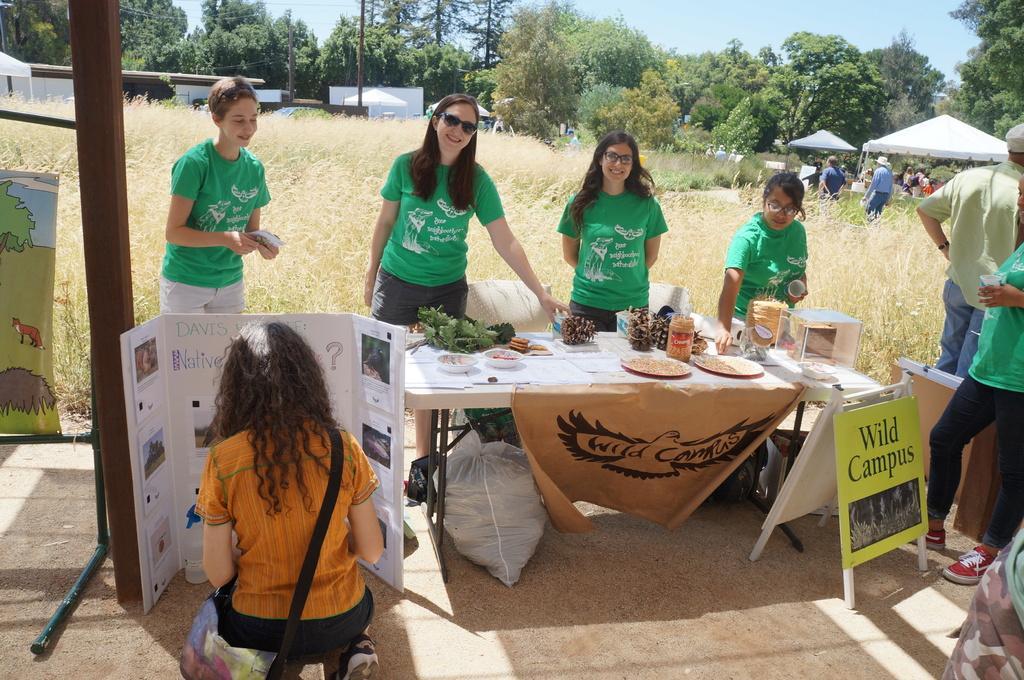Could you give a brief overview of what you see in this image? In this image, few peoples are standing. Near the table and there is a woman is at the bottom of the image. And we can see banners, board. There are few items. On the left side, we can see some map. At the background, we can see few plants and tents and sky. 